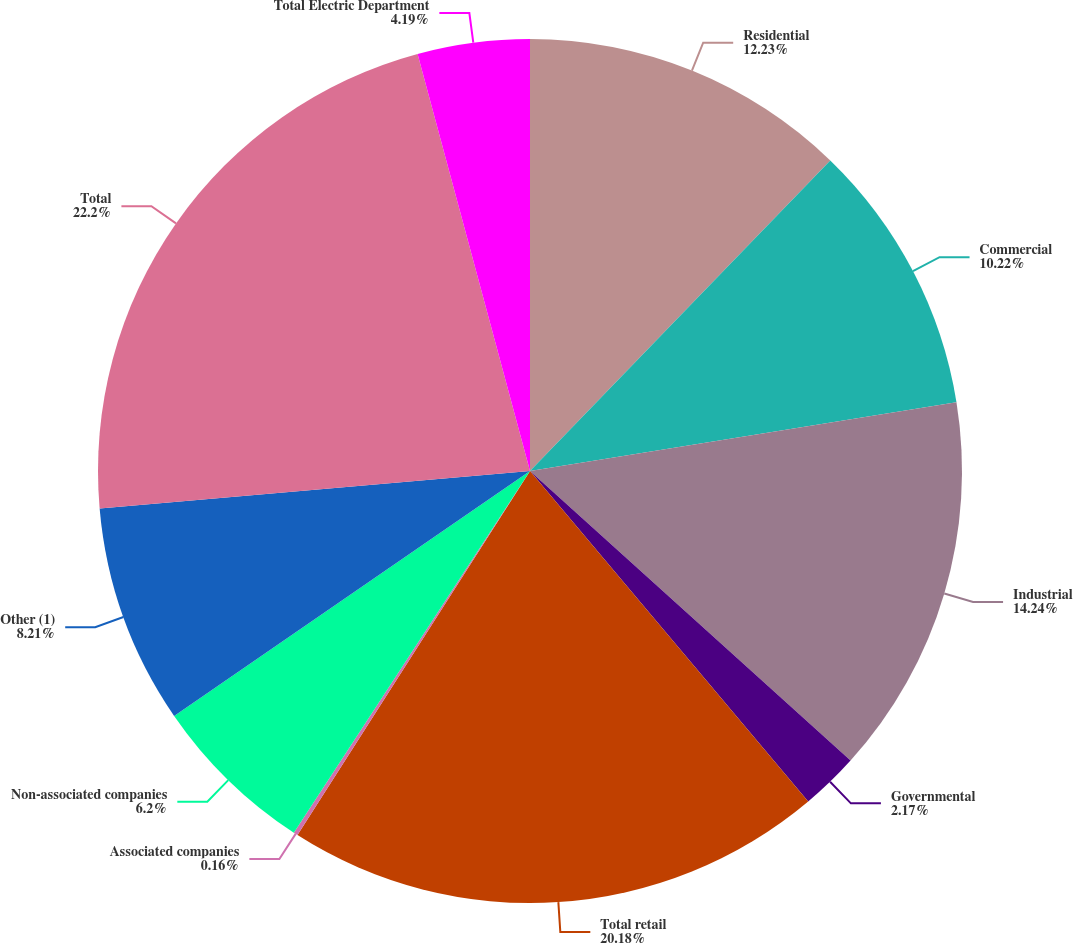<chart> <loc_0><loc_0><loc_500><loc_500><pie_chart><fcel>Residential<fcel>Commercial<fcel>Industrial<fcel>Governmental<fcel>Total retail<fcel>Associated companies<fcel>Non-associated companies<fcel>Other (1)<fcel>Total<fcel>Total Electric Department<nl><fcel>12.23%<fcel>10.22%<fcel>14.24%<fcel>2.17%<fcel>20.18%<fcel>0.16%<fcel>6.2%<fcel>8.21%<fcel>22.19%<fcel>4.19%<nl></chart> 